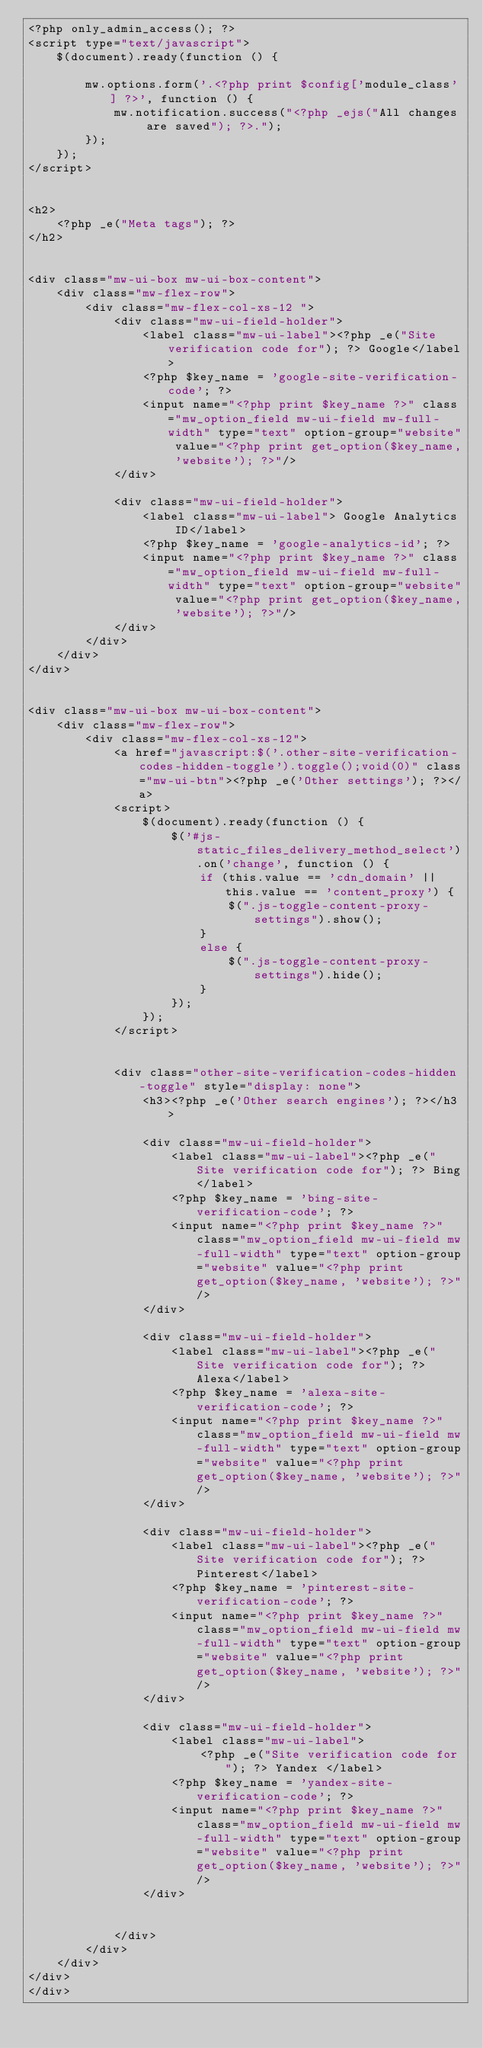Convert code to text. <code><loc_0><loc_0><loc_500><loc_500><_PHP_><?php only_admin_access(); ?>
<script type="text/javascript">
    $(document).ready(function () {

        mw.options.form('.<?php print $config['module_class'] ?>', function () {
            mw.notification.success("<?php _ejs("All changes are saved"); ?>.");
        });
    });
</script>


<h2>
    <?php _e("Meta tags"); ?>
</h2>


<div class="mw-ui-box mw-ui-box-content">
    <div class="mw-flex-row">
        <div class="mw-flex-col-xs-12 ">
            <div class="mw-ui-field-holder">
                <label class="mw-ui-label"><?php _e("Site verification code for"); ?> Google</label>
                <?php $key_name = 'google-site-verification-code'; ?>
                <input name="<?php print $key_name ?>" class="mw_option_field mw-ui-field mw-full-width" type="text" option-group="website" value="<?php print get_option($key_name, 'website'); ?>"/>
            </div>

            <div class="mw-ui-field-holder">
                <label class="mw-ui-label"> Google Analytics ID</label>
                <?php $key_name = 'google-analytics-id'; ?>
                <input name="<?php print $key_name ?>" class="mw_option_field mw-ui-field mw-full-width" type="text" option-group="website" value="<?php print get_option($key_name, 'website'); ?>"/>
            </div>
        </div>
    </div>
</div>


<div class="mw-ui-box mw-ui-box-content">
    <div class="mw-flex-row">
        <div class="mw-flex-col-xs-12">
            <a href="javascript:$('.other-site-verification-codes-hidden-toggle').toggle();void(0)" class="mw-ui-btn"><?php _e('Other settings'); ?></a>
            <script>
                $(document).ready(function () {
                    $('#js-static_files_delivery_method_select').on('change', function () {
                        if (this.value == 'cdn_domain' || this.value == 'content_proxy') {
                            $(".js-toggle-content-proxy-settings").show();
                        }
                        else {
                            $(".js-toggle-content-proxy-settings").hide();
                        }
                    });
                });
            </script>


            <div class="other-site-verification-codes-hidden-toggle" style="display: none">
                <h3><?php _e('Other search engines'); ?></h3>

                <div class="mw-ui-field-holder">
                    <label class="mw-ui-label"><?php _e("Site verification code for"); ?> Bing</label>
                    <?php $key_name = 'bing-site-verification-code'; ?>
                    <input name="<?php print $key_name ?>" class="mw_option_field mw-ui-field mw-full-width" type="text" option-group="website" value="<?php print get_option($key_name, 'website'); ?>"/>
                </div>

                <div class="mw-ui-field-holder">
                    <label class="mw-ui-label"><?php _e("Site verification code for"); ?> Alexa</label>
                    <?php $key_name = 'alexa-site-verification-code'; ?>
                    <input name="<?php print $key_name ?>" class="mw_option_field mw-ui-field mw-full-width" type="text" option-group="website" value="<?php print get_option($key_name, 'website'); ?>"/>
                </div>

                <div class="mw-ui-field-holder">
                    <label class="mw-ui-label"><?php _e("Site verification code for"); ?> Pinterest</label>
                    <?php $key_name = 'pinterest-site-verification-code'; ?>
                    <input name="<?php print $key_name ?>" class="mw_option_field mw-ui-field mw-full-width" type="text" option-group="website" value="<?php print get_option($key_name, 'website'); ?>"/>
                </div>

                <div class="mw-ui-field-holder">
                    <label class="mw-ui-label">
                        <?php _e("Site verification code for"); ?> Yandex </label>
                    <?php $key_name = 'yandex-site-verification-code'; ?>
                    <input name="<?php print $key_name ?>" class="mw_option_field mw-ui-field mw-full-width" type="text" option-group="website" value="<?php print get_option($key_name, 'website'); ?>"/>
                </div>


            </div>
        </div>
    </div>
</div>
</div>
</code> 